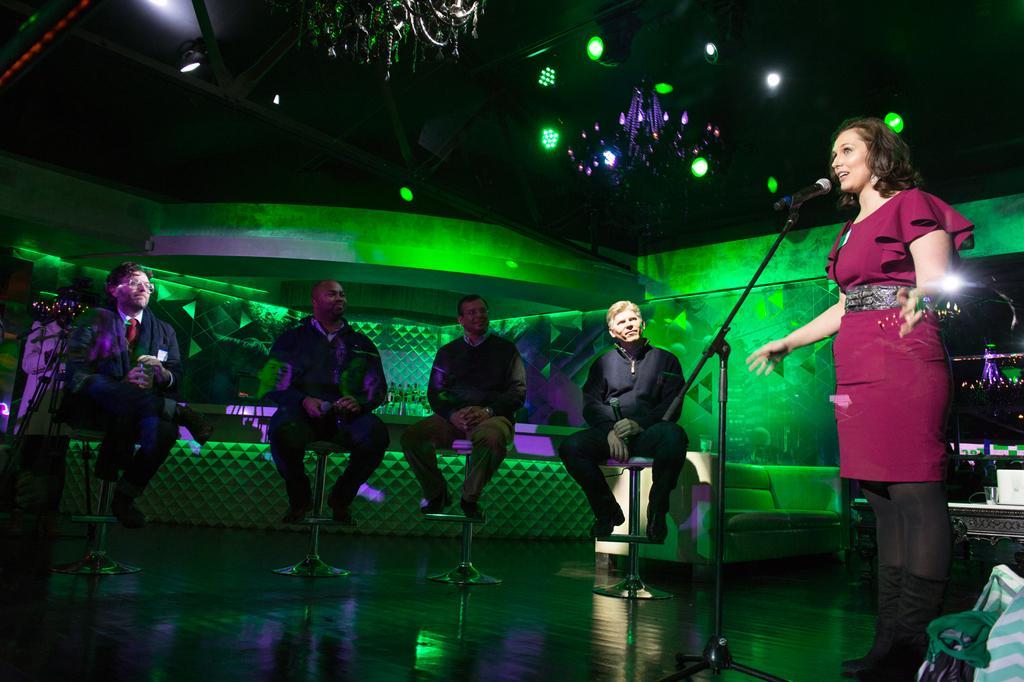Describe this image in one or two sentences. On the right side of the image there is a person standing in front of the mike. There are people sitting on the chairs. At the bottom of the image there is a floor. On the right side of the image there is some object. On top of the image there are chandeliers. There are lights. In the background of the image there is a sofa. There are few bottle on the platform. 